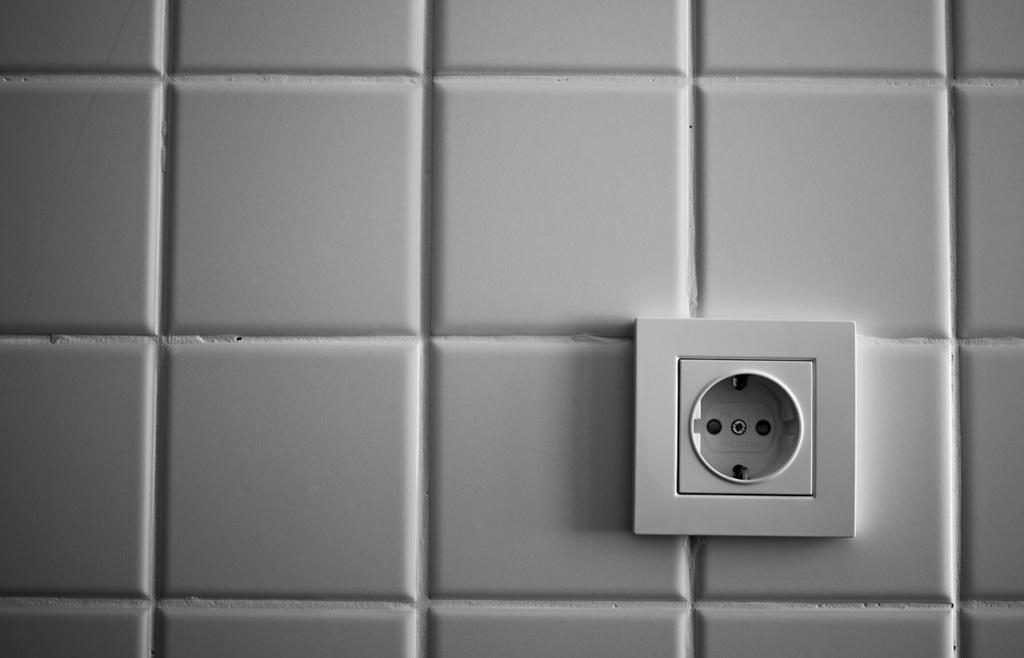What can be seen attached to the wall in the image? There is a socket in the image. How is the socket connected to the wall? The socket is fixed to the wall. What type of flower is growing near the socket in the image? There is no flower present in the image; it only features a socket fixed to the wall. 